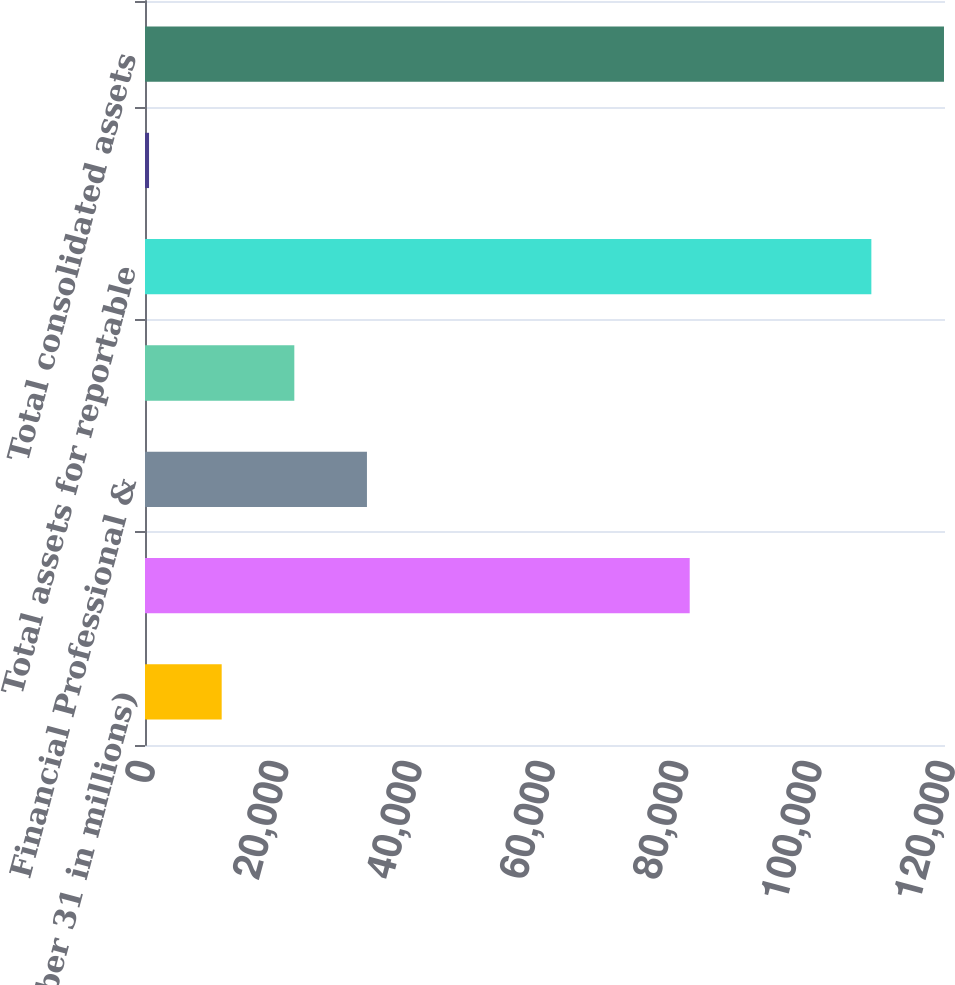Convert chart. <chart><loc_0><loc_0><loc_500><loc_500><bar_chart><fcel>(at December 31 in millions)<fcel>Business Insurance<fcel>Financial Professional &<fcel>Personal Insurance<fcel>Total assets for reportable<fcel>Other assets(1)<fcel>Total consolidated assets<nl><fcel>11502.3<fcel>81705<fcel>33292.9<fcel>22397.6<fcel>108953<fcel>607<fcel>119848<nl></chart> 